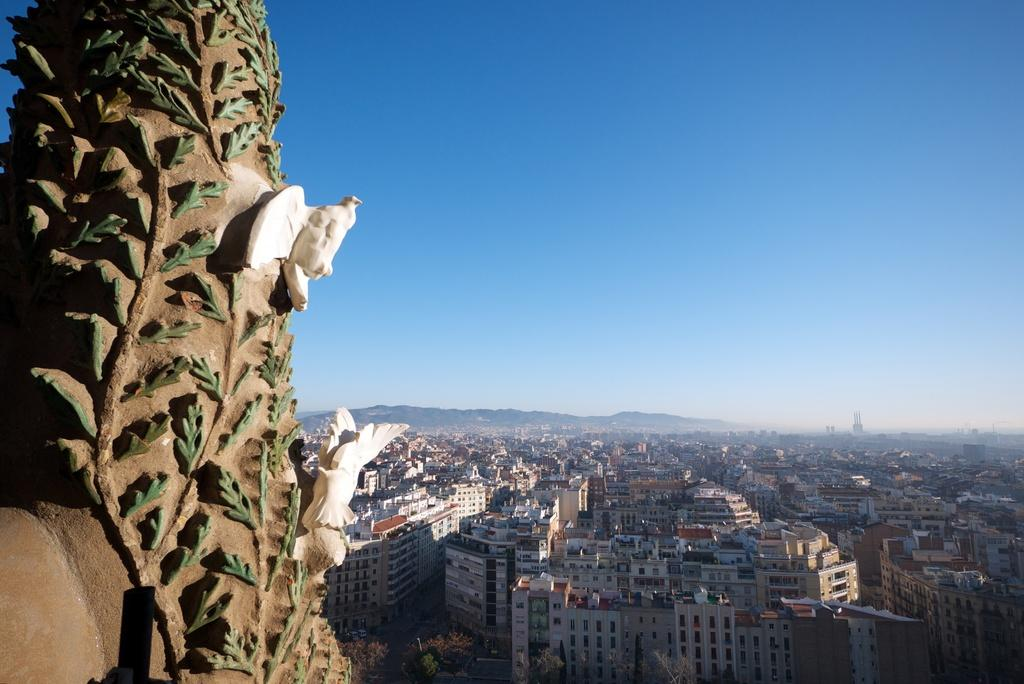What is located on the left side of the image? There is a structure on the left side of the image. What can be seen on the structure? There are birds on the structure. What is visible in the background of the image? There are buildings and hills in the background of the image. How would you describe the sky in the image? The sky is clear in the image. How many tomatoes are hanging from the structure in the image? There are no tomatoes present in the image; the structure has birds on it. What is the temper of the birds in the image? There is no information about the temper of the birds in the image, as their behavior is not described. 